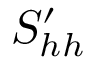<formula> <loc_0><loc_0><loc_500><loc_500>S _ { h h } ^ { \prime }</formula> 